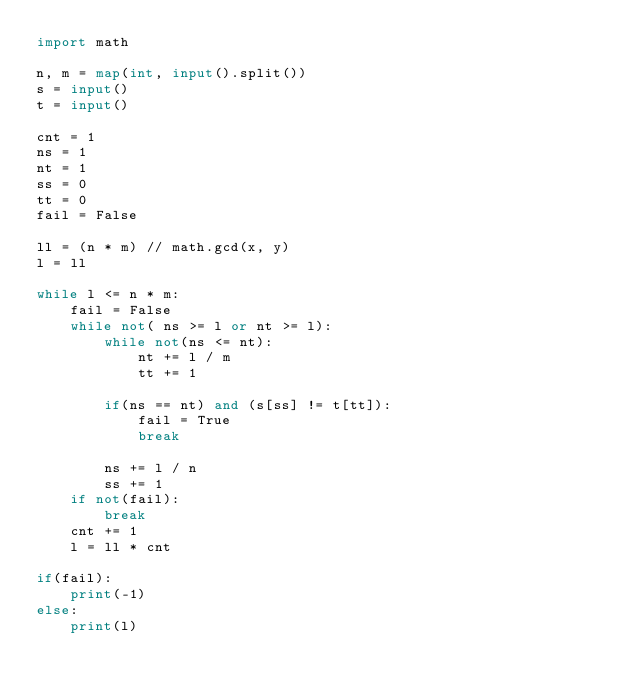Convert code to text. <code><loc_0><loc_0><loc_500><loc_500><_Python_>import math

n, m = map(int, input().split())
s = input()
t = input()

cnt = 1
ns = 1
nt = 1
ss = 0
tt = 0
fail = False

ll = (n * m) // math.gcd(x, y)
l = ll

while l <= n * m:
    fail = False
    while not( ns >= l or nt >= l):
        while not(ns <= nt):
            nt += l / m 
            tt += 1

        if(ns == nt) and (s[ss] != t[tt]):
            fail = True
            break

        ns += l / n
        ss += 1
    if not(fail): 
        break
    cnt += 1
    l = ll * cnt

if(fail):
    print(-1)
else:
    print(l)
</code> 